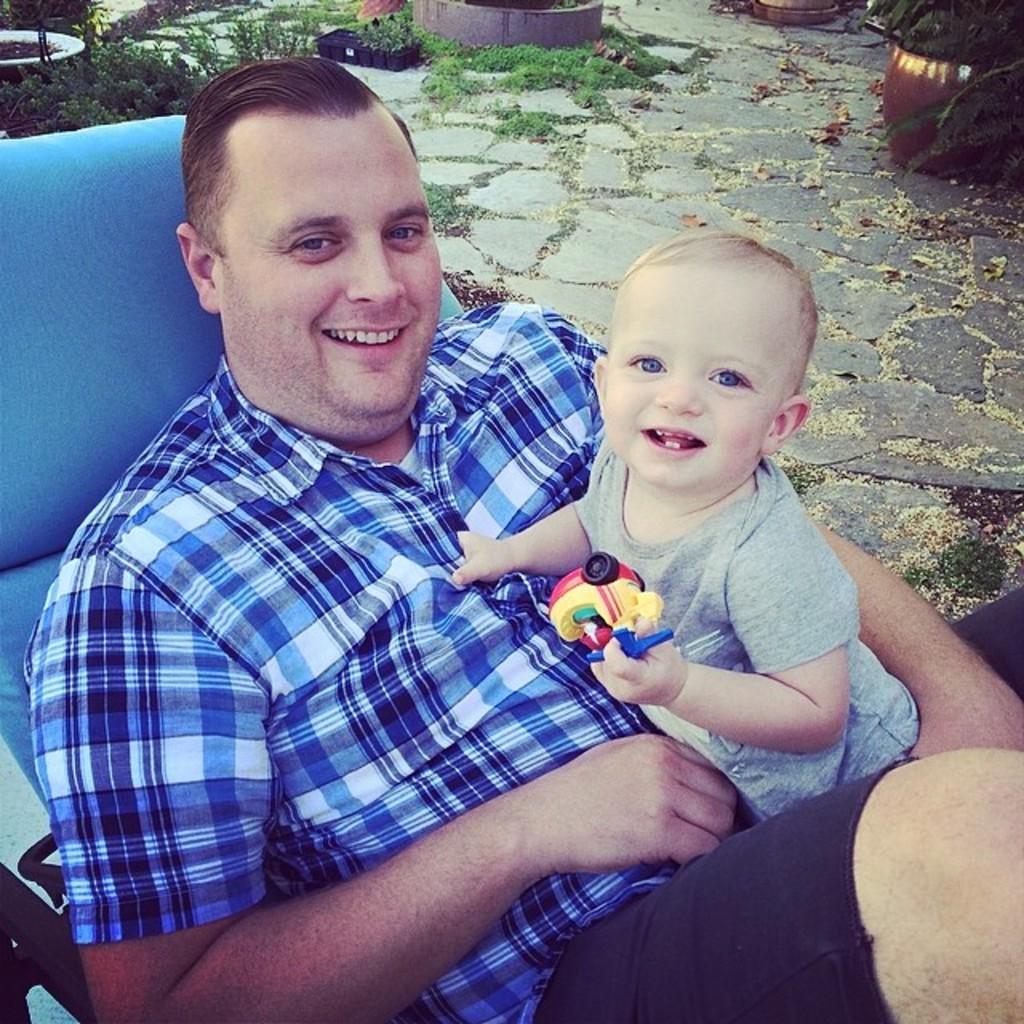Please provide a concise description of this image. As we can see in the image there is a person wearing blue color shirt and sitting on chair. The child over here is holding a toy. In the background there is grass and pot. 